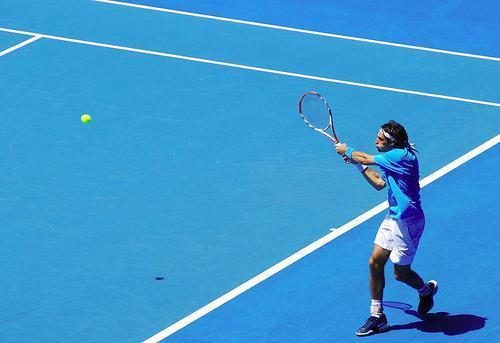How many people are visible?
Give a very brief answer. 1. 